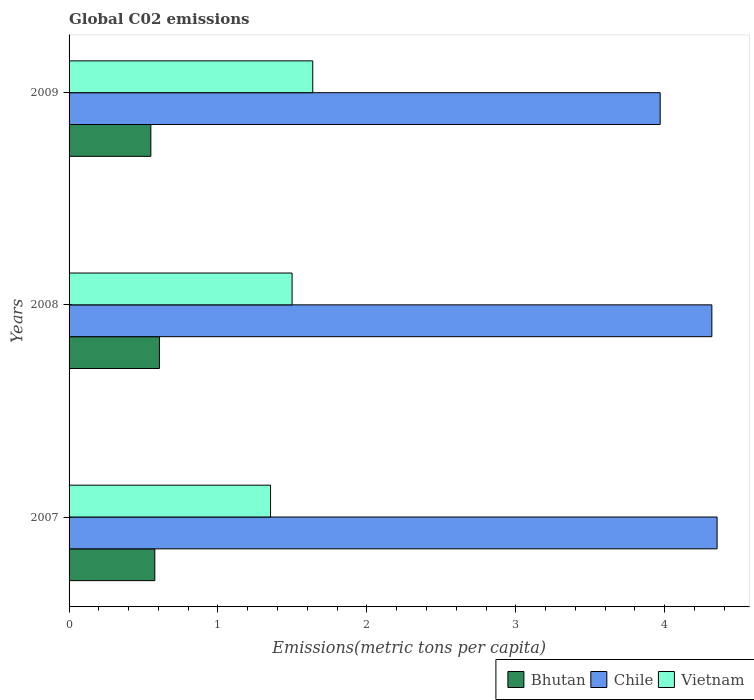How many different coloured bars are there?
Make the answer very short. 3. How many bars are there on the 2nd tick from the top?
Provide a succinct answer. 3. How many bars are there on the 1st tick from the bottom?
Offer a very short reply. 3. What is the label of the 1st group of bars from the top?
Make the answer very short. 2009. In how many cases, is the number of bars for a given year not equal to the number of legend labels?
Your answer should be compact. 0. What is the amount of CO2 emitted in in Vietnam in 2009?
Give a very brief answer. 1.64. Across all years, what is the maximum amount of CO2 emitted in in Bhutan?
Give a very brief answer. 0.61. Across all years, what is the minimum amount of CO2 emitted in in Vietnam?
Your answer should be very brief. 1.35. In which year was the amount of CO2 emitted in in Vietnam maximum?
Your response must be concise. 2009. What is the total amount of CO2 emitted in in Vietnam in the graph?
Your answer should be compact. 4.49. What is the difference between the amount of CO2 emitted in in Chile in 2008 and that in 2009?
Your answer should be very brief. 0.35. What is the difference between the amount of CO2 emitted in in Bhutan in 2009 and the amount of CO2 emitted in in Chile in 2007?
Your response must be concise. -3.8. What is the average amount of CO2 emitted in in Chile per year?
Give a very brief answer. 4.21. In the year 2008, what is the difference between the amount of CO2 emitted in in Bhutan and amount of CO2 emitted in in Vietnam?
Provide a short and direct response. -0.89. In how many years, is the amount of CO2 emitted in in Chile greater than 2.6 metric tons per capita?
Give a very brief answer. 3. What is the ratio of the amount of CO2 emitted in in Bhutan in 2008 to that in 2009?
Give a very brief answer. 1.1. Is the difference between the amount of CO2 emitted in in Bhutan in 2007 and 2009 greater than the difference between the amount of CO2 emitted in in Vietnam in 2007 and 2009?
Provide a short and direct response. Yes. What is the difference between the highest and the second highest amount of CO2 emitted in in Bhutan?
Give a very brief answer. 0.03. What is the difference between the highest and the lowest amount of CO2 emitted in in Chile?
Give a very brief answer. 0.38. In how many years, is the amount of CO2 emitted in in Vietnam greater than the average amount of CO2 emitted in in Vietnam taken over all years?
Give a very brief answer. 2. What does the 2nd bar from the top in 2007 represents?
Offer a terse response. Chile. What does the 3rd bar from the bottom in 2007 represents?
Keep it short and to the point. Vietnam. Are all the bars in the graph horizontal?
Your answer should be compact. Yes. What is the difference between two consecutive major ticks on the X-axis?
Offer a very short reply. 1. Does the graph contain any zero values?
Offer a terse response. No. Does the graph contain grids?
Give a very brief answer. No. How are the legend labels stacked?
Make the answer very short. Horizontal. What is the title of the graph?
Give a very brief answer. Global C02 emissions. What is the label or title of the X-axis?
Keep it short and to the point. Emissions(metric tons per capita). What is the Emissions(metric tons per capita) of Bhutan in 2007?
Provide a short and direct response. 0.58. What is the Emissions(metric tons per capita) in Chile in 2007?
Your answer should be very brief. 4.35. What is the Emissions(metric tons per capita) in Vietnam in 2007?
Keep it short and to the point. 1.35. What is the Emissions(metric tons per capita) of Bhutan in 2008?
Provide a succinct answer. 0.61. What is the Emissions(metric tons per capita) in Chile in 2008?
Your answer should be compact. 4.32. What is the Emissions(metric tons per capita) in Vietnam in 2008?
Make the answer very short. 1.5. What is the Emissions(metric tons per capita) in Bhutan in 2009?
Provide a succinct answer. 0.55. What is the Emissions(metric tons per capita) of Chile in 2009?
Make the answer very short. 3.97. What is the Emissions(metric tons per capita) in Vietnam in 2009?
Provide a succinct answer. 1.64. Across all years, what is the maximum Emissions(metric tons per capita) of Bhutan?
Provide a short and direct response. 0.61. Across all years, what is the maximum Emissions(metric tons per capita) in Chile?
Make the answer very short. 4.35. Across all years, what is the maximum Emissions(metric tons per capita) in Vietnam?
Ensure brevity in your answer.  1.64. Across all years, what is the minimum Emissions(metric tons per capita) of Bhutan?
Provide a succinct answer. 0.55. Across all years, what is the minimum Emissions(metric tons per capita) in Chile?
Give a very brief answer. 3.97. Across all years, what is the minimum Emissions(metric tons per capita) of Vietnam?
Your answer should be compact. 1.35. What is the total Emissions(metric tons per capita) of Bhutan in the graph?
Offer a terse response. 1.73. What is the total Emissions(metric tons per capita) of Chile in the graph?
Provide a short and direct response. 12.64. What is the total Emissions(metric tons per capita) of Vietnam in the graph?
Your answer should be very brief. 4.49. What is the difference between the Emissions(metric tons per capita) in Bhutan in 2007 and that in 2008?
Offer a very short reply. -0.03. What is the difference between the Emissions(metric tons per capita) in Chile in 2007 and that in 2008?
Keep it short and to the point. 0.04. What is the difference between the Emissions(metric tons per capita) in Vietnam in 2007 and that in 2008?
Ensure brevity in your answer.  -0.14. What is the difference between the Emissions(metric tons per capita) in Bhutan in 2007 and that in 2009?
Make the answer very short. 0.03. What is the difference between the Emissions(metric tons per capita) in Chile in 2007 and that in 2009?
Your answer should be compact. 0.38. What is the difference between the Emissions(metric tons per capita) of Vietnam in 2007 and that in 2009?
Your answer should be compact. -0.28. What is the difference between the Emissions(metric tons per capita) in Bhutan in 2008 and that in 2009?
Give a very brief answer. 0.06. What is the difference between the Emissions(metric tons per capita) of Chile in 2008 and that in 2009?
Give a very brief answer. 0.35. What is the difference between the Emissions(metric tons per capita) in Vietnam in 2008 and that in 2009?
Give a very brief answer. -0.14. What is the difference between the Emissions(metric tons per capita) of Bhutan in 2007 and the Emissions(metric tons per capita) of Chile in 2008?
Offer a very short reply. -3.74. What is the difference between the Emissions(metric tons per capita) in Bhutan in 2007 and the Emissions(metric tons per capita) in Vietnam in 2008?
Offer a terse response. -0.92. What is the difference between the Emissions(metric tons per capita) in Chile in 2007 and the Emissions(metric tons per capita) in Vietnam in 2008?
Your answer should be very brief. 2.85. What is the difference between the Emissions(metric tons per capita) of Bhutan in 2007 and the Emissions(metric tons per capita) of Chile in 2009?
Make the answer very short. -3.39. What is the difference between the Emissions(metric tons per capita) of Bhutan in 2007 and the Emissions(metric tons per capita) of Vietnam in 2009?
Your answer should be very brief. -1.06. What is the difference between the Emissions(metric tons per capita) of Chile in 2007 and the Emissions(metric tons per capita) of Vietnam in 2009?
Offer a terse response. 2.72. What is the difference between the Emissions(metric tons per capita) of Bhutan in 2008 and the Emissions(metric tons per capita) of Chile in 2009?
Provide a succinct answer. -3.36. What is the difference between the Emissions(metric tons per capita) in Bhutan in 2008 and the Emissions(metric tons per capita) in Vietnam in 2009?
Give a very brief answer. -1.03. What is the difference between the Emissions(metric tons per capita) in Chile in 2008 and the Emissions(metric tons per capita) in Vietnam in 2009?
Keep it short and to the point. 2.68. What is the average Emissions(metric tons per capita) in Bhutan per year?
Ensure brevity in your answer.  0.58. What is the average Emissions(metric tons per capita) in Chile per year?
Ensure brevity in your answer.  4.21. What is the average Emissions(metric tons per capita) of Vietnam per year?
Provide a succinct answer. 1.5. In the year 2007, what is the difference between the Emissions(metric tons per capita) in Bhutan and Emissions(metric tons per capita) in Chile?
Ensure brevity in your answer.  -3.78. In the year 2007, what is the difference between the Emissions(metric tons per capita) in Bhutan and Emissions(metric tons per capita) in Vietnam?
Your response must be concise. -0.78. In the year 2007, what is the difference between the Emissions(metric tons per capita) of Chile and Emissions(metric tons per capita) of Vietnam?
Your response must be concise. 3. In the year 2008, what is the difference between the Emissions(metric tons per capita) in Bhutan and Emissions(metric tons per capita) in Chile?
Offer a terse response. -3.71. In the year 2008, what is the difference between the Emissions(metric tons per capita) in Bhutan and Emissions(metric tons per capita) in Vietnam?
Your response must be concise. -0.89. In the year 2008, what is the difference between the Emissions(metric tons per capita) in Chile and Emissions(metric tons per capita) in Vietnam?
Your answer should be very brief. 2.82. In the year 2009, what is the difference between the Emissions(metric tons per capita) in Bhutan and Emissions(metric tons per capita) in Chile?
Offer a terse response. -3.42. In the year 2009, what is the difference between the Emissions(metric tons per capita) in Bhutan and Emissions(metric tons per capita) in Vietnam?
Provide a succinct answer. -1.09. In the year 2009, what is the difference between the Emissions(metric tons per capita) of Chile and Emissions(metric tons per capita) of Vietnam?
Your answer should be compact. 2.33. What is the ratio of the Emissions(metric tons per capita) of Bhutan in 2007 to that in 2008?
Make the answer very short. 0.95. What is the ratio of the Emissions(metric tons per capita) of Vietnam in 2007 to that in 2008?
Keep it short and to the point. 0.9. What is the ratio of the Emissions(metric tons per capita) of Bhutan in 2007 to that in 2009?
Your answer should be very brief. 1.05. What is the ratio of the Emissions(metric tons per capita) of Chile in 2007 to that in 2009?
Ensure brevity in your answer.  1.1. What is the ratio of the Emissions(metric tons per capita) of Vietnam in 2007 to that in 2009?
Offer a terse response. 0.83. What is the ratio of the Emissions(metric tons per capita) of Bhutan in 2008 to that in 2009?
Ensure brevity in your answer.  1.1. What is the ratio of the Emissions(metric tons per capita) in Chile in 2008 to that in 2009?
Your response must be concise. 1.09. What is the ratio of the Emissions(metric tons per capita) of Vietnam in 2008 to that in 2009?
Your response must be concise. 0.92. What is the difference between the highest and the second highest Emissions(metric tons per capita) of Bhutan?
Make the answer very short. 0.03. What is the difference between the highest and the second highest Emissions(metric tons per capita) in Chile?
Provide a short and direct response. 0.04. What is the difference between the highest and the second highest Emissions(metric tons per capita) in Vietnam?
Offer a very short reply. 0.14. What is the difference between the highest and the lowest Emissions(metric tons per capita) of Bhutan?
Offer a very short reply. 0.06. What is the difference between the highest and the lowest Emissions(metric tons per capita) of Chile?
Your answer should be very brief. 0.38. What is the difference between the highest and the lowest Emissions(metric tons per capita) of Vietnam?
Your answer should be compact. 0.28. 